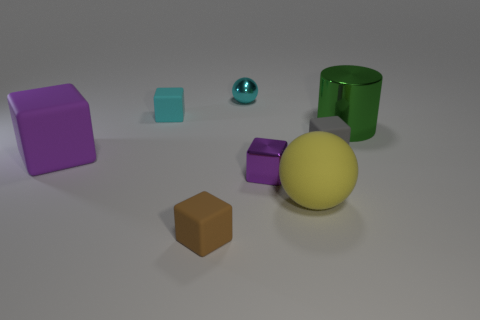Subtract all large blocks. How many blocks are left? 4 Subtract all blue balls. How many purple blocks are left? 2 Subtract all cyan cubes. How many cubes are left? 4 Subtract 2 blocks. How many blocks are left? 3 Add 1 tiny shiny things. How many objects exist? 9 Subtract all spheres. How many objects are left? 6 Subtract all cyan blocks. Subtract all purple balls. How many blocks are left? 4 Subtract 0 purple cylinders. How many objects are left? 8 Subtract all small gray rubber objects. Subtract all small cyan shiny balls. How many objects are left? 6 Add 4 yellow objects. How many yellow objects are left? 5 